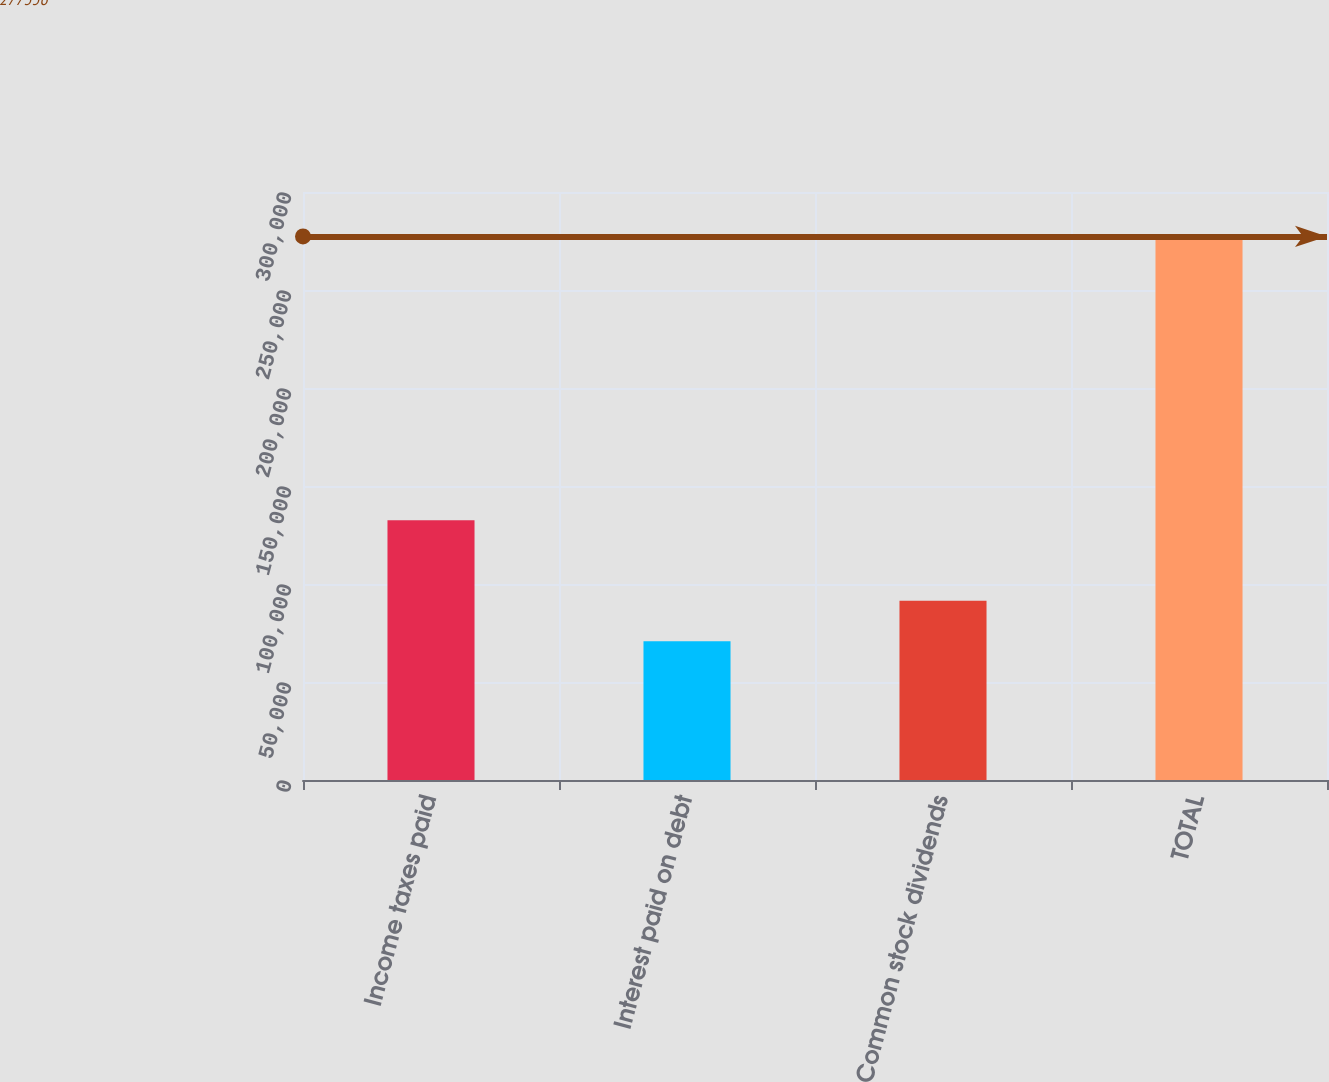Convert chart to OTSL. <chart><loc_0><loc_0><loc_500><loc_500><bar_chart><fcel>Income taxes paid<fcel>Interest paid on debt<fcel>Common stock dividends<fcel>TOTAL<nl><fcel>132487<fcel>70741<fcel>91402.5<fcel>277356<nl></chart> 